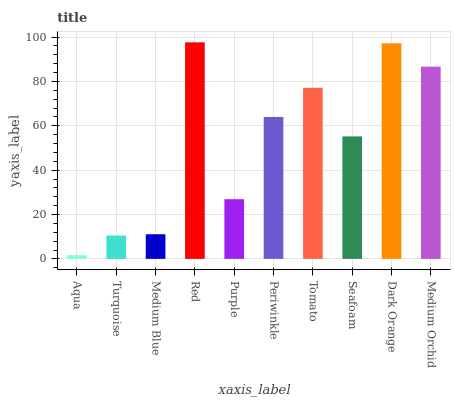Is Aqua the minimum?
Answer yes or no. Yes. Is Red the maximum?
Answer yes or no. Yes. Is Turquoise the minimum?
Answer yes or no. No. Is Turquoise the maximum?
Answer yes or no. No. Is Turquoise greater than Aqua?
Answer yes or no. Yes. Is Aqua less than Turquoise?
Answer yes or no. Yes. Is Aqua greater than Turquoise?
Answer yes or no. No. Is Turquoise less than Aqua?
Answer yes or no. No. Is Periwinkle the high median?
Answer yes or no. Yes. Is Seafoam the low median?
Answer yes or no. Yes. Is Red the high median?
Answer yes or no. No. Is Medium Orchid the low median?
Answer yes or no. No. 